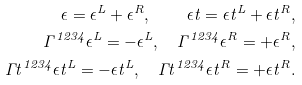Convert formula to latex. <formula><loc_0><loc_0><loc_500><loc_500>\epsilon = \epsilon ^ { L } + \epsilon ^ { R } , \quad \epsilon t = \epsilon t ^ { L } + \epsilon t ^ { R } , \\ \Gamma ^ { 1 2 3 4 } \epsilon ^ { L } = - \epsilon ^ { L } , \quad \Gamma ^ { 1 2 3 4 } \epsilon ^ { R } = + \epsilon ^ { R } , \\ \Gamma t ^ { 1 2 3 4 } \epsilon t ^ { L } = - \epsilon t ^ { L } , \quad \Gamma t ^ { 1 2 3 4 } \epsilon t ^ { R } = + \epsilon t ^ { R } .</formula> 